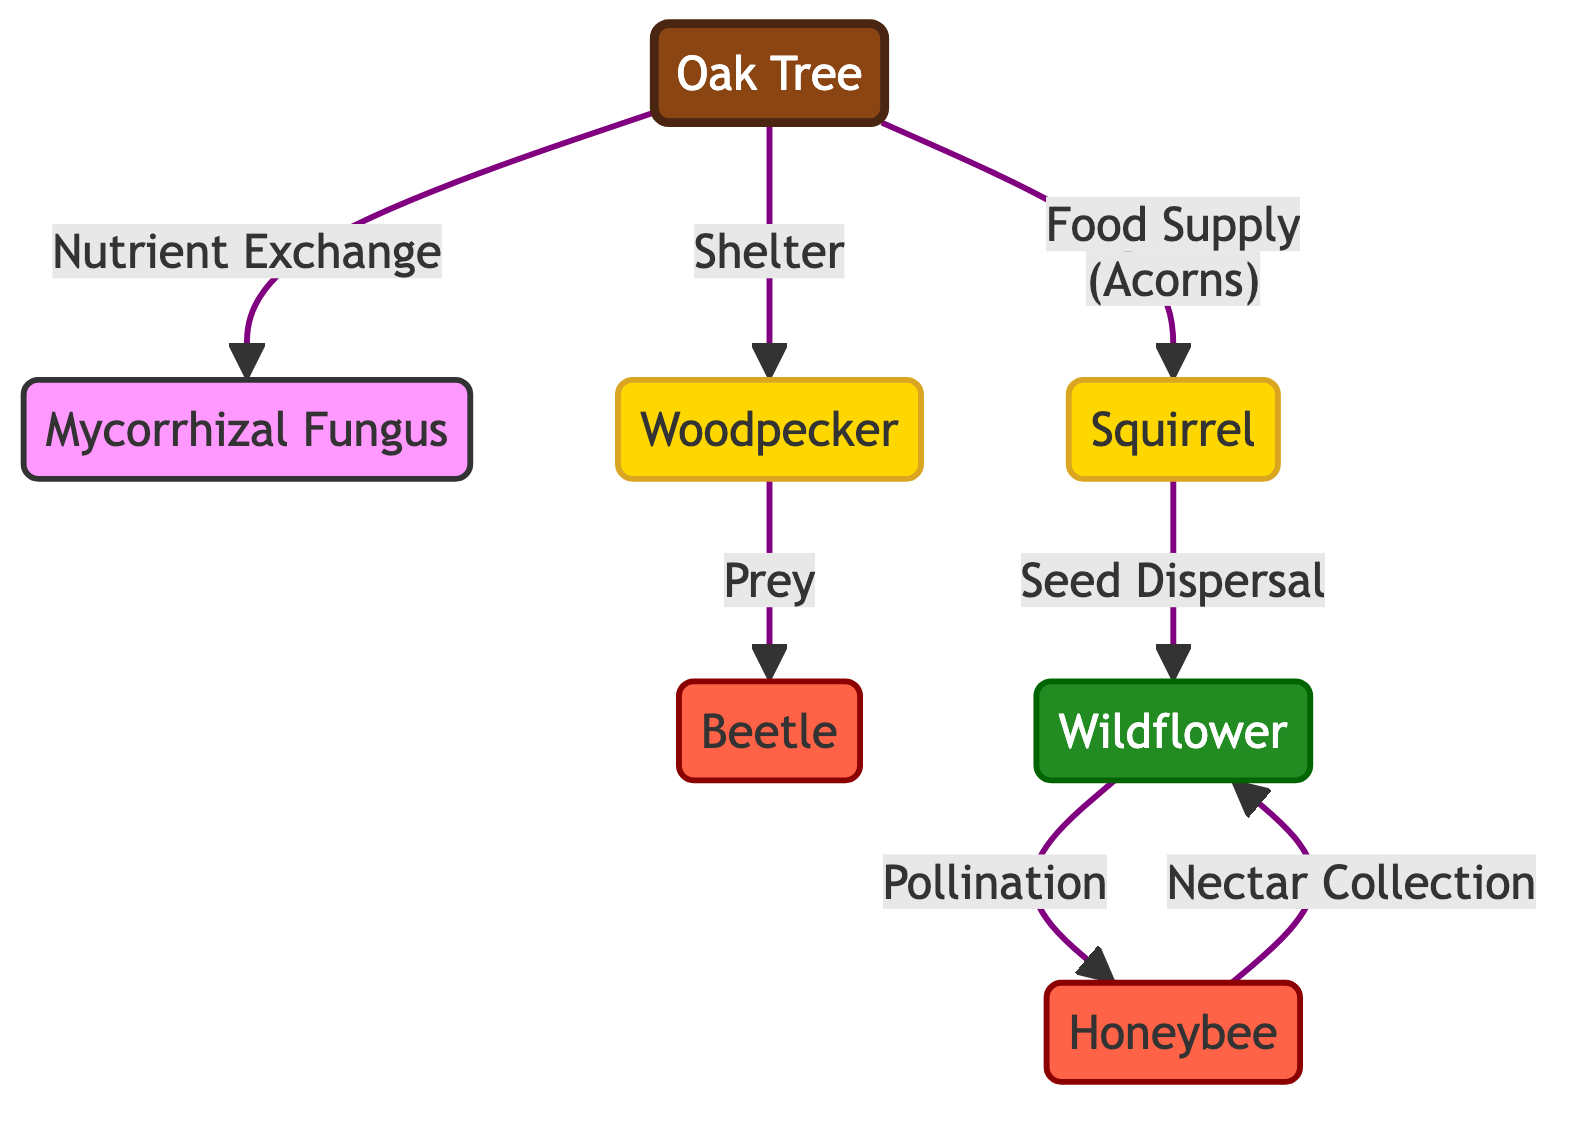What is the main tree depicted in the diagram? The main tree represented in the diagram is labeled as "Oak Tree." This can be found at the top of the diagram, clearly indicated by its distinct node shape and color.
Answer: Oak Tree How many insect-related nodes are shown in the diagram? In the diagram, there are two insect-related nodes: "Bee" and "Beetle." By counting the distinct nodes associated with insects, it is clear that both of these labels represent different insect species.
Answer: 2 What relationship does the "Squirrel" have with the "Wildflower"? The relationship between "Squirrel" and "Wildflower" is described as "Seed Dispersal." By following the arrows in the diagram, it indicates that the Squirrel aids in spreading the seeds of the Wildflower.
Answer: Seed Dispersal Which node provides "Shelter" to the "Woodpecker"? The "Oak Tree" provides "Shelter" to the "Woodpecker." The arrow from the Oak Tree pointing to the Woodpecker signifies that this tree serves as a habitat for the bird.
Answer: Oak Tree What role does the "Bee" play in relation to the "Wildflower"? The "Bee" plays the role of "Pollination" in relation to the "Wildflower." This is depicted by the directed arrow indicating the relationship mentioned in the diagram.
Answer: Pollination What nutrient relationship exists between the "Oak Tree" and the "Mycorrhizal Fungus"? The relationship between the "Oak Tree" and the "Mycorrhizal Fungus" is described as "Nutrient Exchange." This indicates a mutual relationship where both organisms benefit from sharing resources.
Answer: Nutrient Exchange Which animal preys on the "Insect"? The "Woodpecker" preys on the "Insect," as indicated by the directed relationship pointing from the Woodpecker to an insect node in the diagram.
Answer: Woodpecker How does "Wildflower" benefit from the "Bee"? The "Wildflower" benefits from the "Bee" through "Nectar Collection." The direct relationship is represented in the diagram showing how bees gather nectar from flowers, aiding their reproduction.
Answer: Nectar Collection 